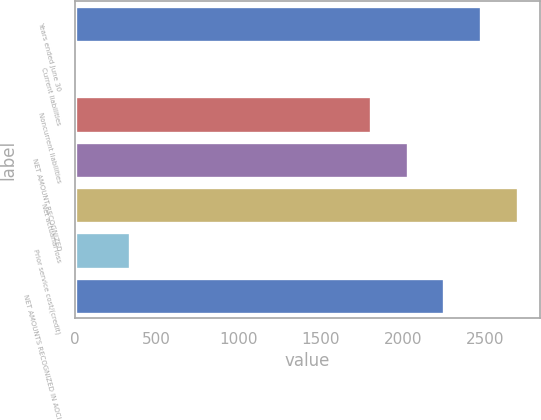Convert chart to OTSL. <chart><loc_0><loc_0><loc_500><loc_500><bar_chart><fcel>Years ended June 30<fcel>Current liabilities<fcel>Noncurrent liabilities<fcel>NET AMOUNT RECOGNIZED<fcel>Net actuarial loss<fcel>Prior service cost/(credit)<fcel>NET AMOUNTS RECOGNIZED IN AOCI<nl><fcel>2475.8<fcel>21<fcel>1808<fcel>2030.6<fcel>2698.4<fcel>334<fcel>2253.2<nl></chart> 